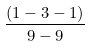Convert formula to latex. <formula><loc_0><loc_0><loc_500><loc_500>\frac { ( 1 - 3 - 1 ) } { 9 - 9 }</formula> 